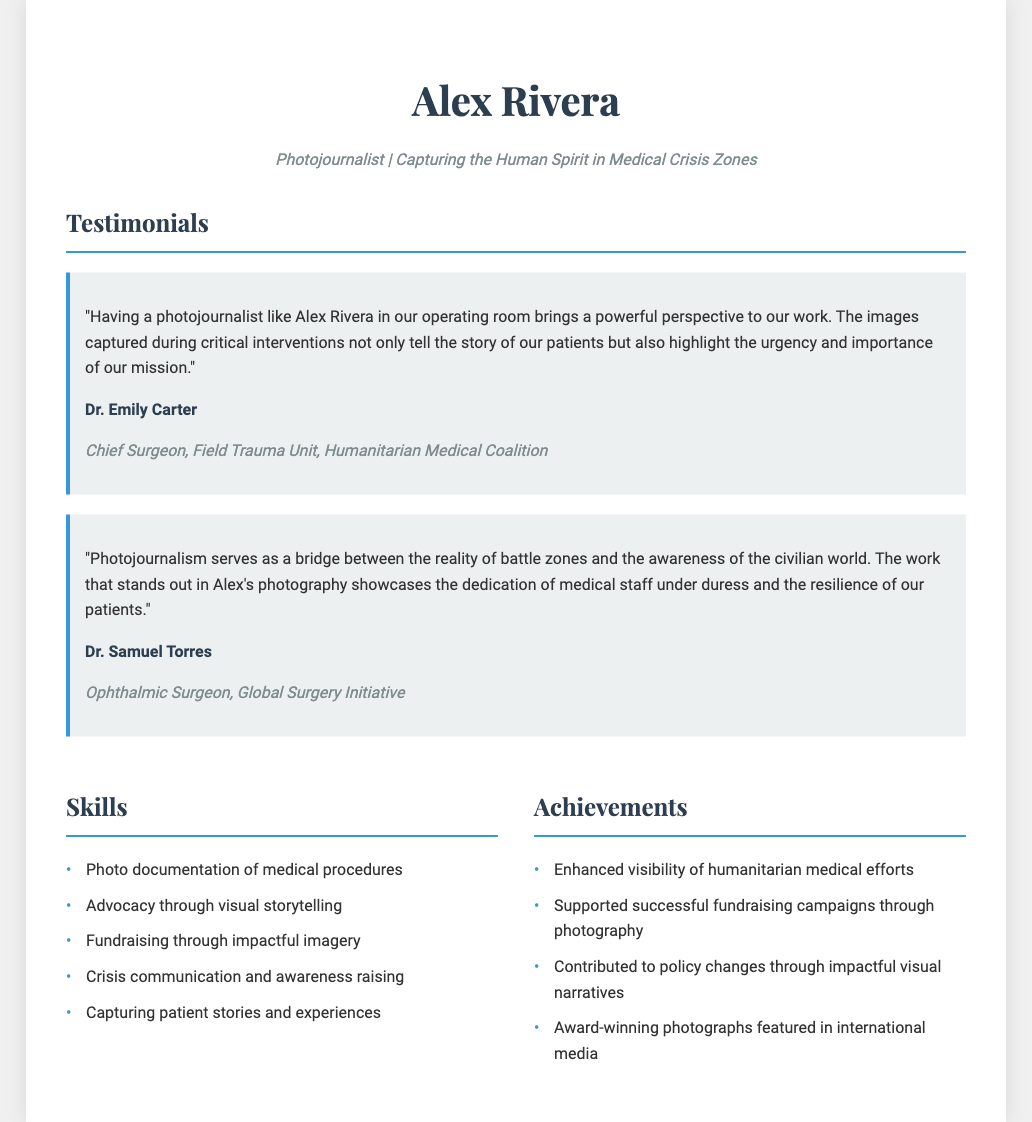What is the name of the photojournalist? The document states the name of the photojournalist at the beginning, which is Alex Rivera.
Answer: Alex Rivera Who is the Chief Surgeon mentioned in the testimonials? The document includes a testimonial from a Chief Surgeon, identified as Dr. Emily Carter.
Answer: Dr. Emily Carter What is one of the key skills listed in the resume? The document provides a list of skills, one of which is "Photo documentation of medical procedures."
Answer: Photo documentation of medical procedures How many testimonials are included in the document? There are two testimonials presented from different surgeons in the document.
Answer: Two Which organization is associated with Dr. Samuel Torres? The document specifies that Dr. Samuel Torres is affiliated with the Global Surgery Initiative.
Answer: Global Surgery Initiative What emotion do the testimonials communicate about the photojournalist's work? Both testimonials reflect appreciation for the photojournalist's role in highlighting the importance of medical efforts, indicating the impact of the work.
Answer: Appreciation What is one of the achievements mentioned in the resume? The resume includes achievements, one stating "Enhanced visibility of humanitarian medical efforts."
Answer: Enhanced visibility of humanitarian medical efforts What type of work does Alex Rivera primarily focus on? The resume highlights that Alex Rivera captures the "Human Spirit in Medical Crisis Zones."
Answer: Medical Crisis Zones 